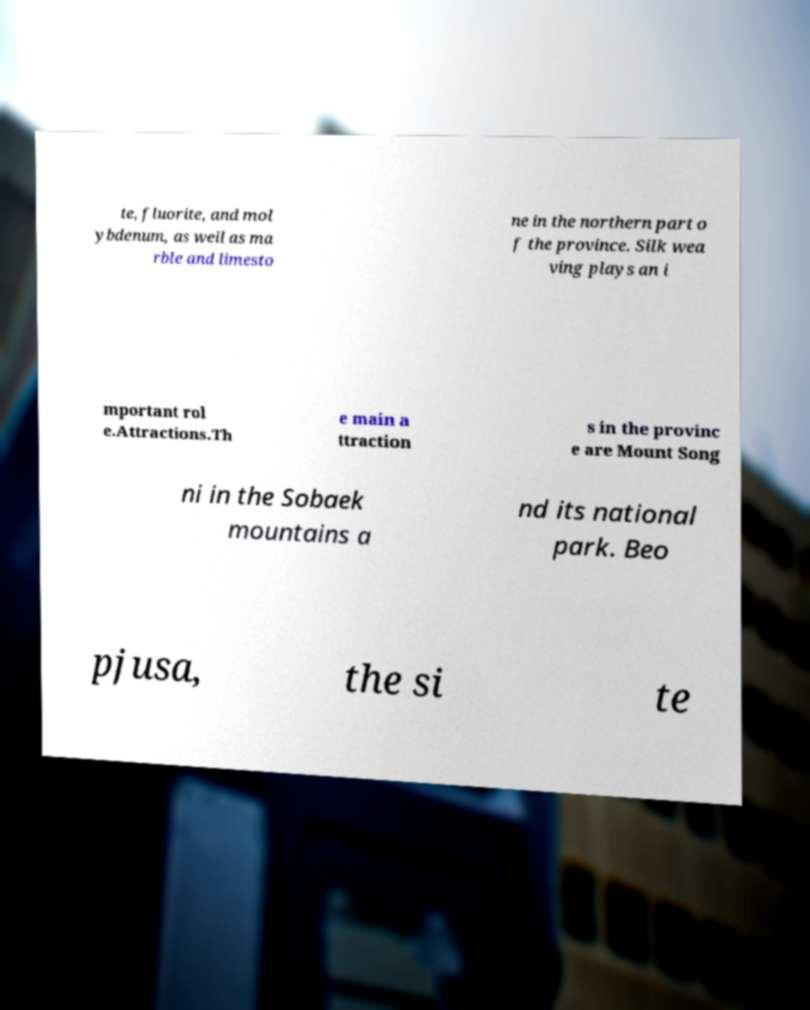Can you accurately transcribe the text from the provided image for me? te, fluorite, and mol ybdenum, as well as ma rble and limesto ne in the northern part o f the province. Silk wea ving plays an i mportant rol e.Attractions.Th e main a ttraction s in the provinc e are Mount Song ni in the Sobaek mountains a nd its national park. Beo pjusa, the si te 